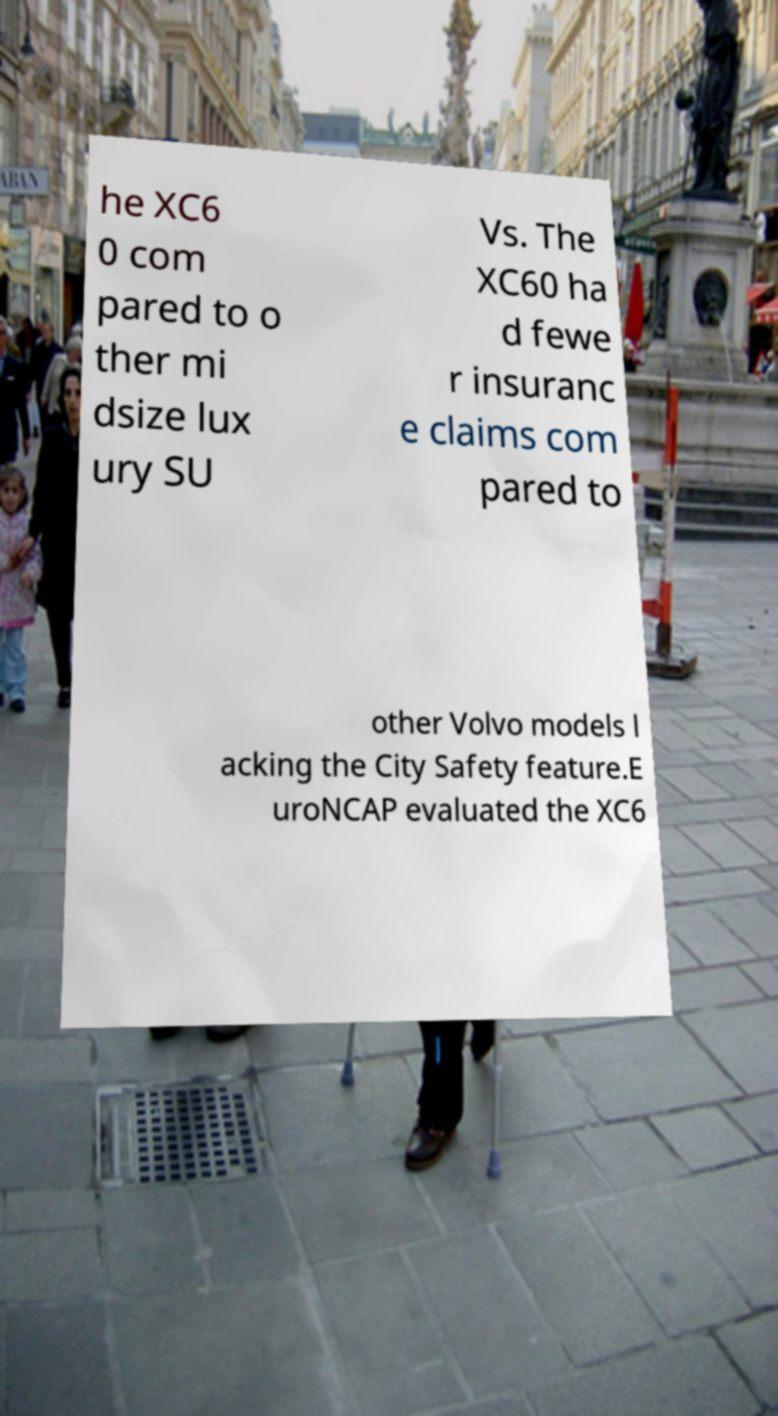What messages or text are displayed in this image? I need them in a readable, typed format. he XC6 0 com pared to o ther mi dsize lux ury SU Vs. The XC60 ha d fewe r insuranc e claims com pared to other Volvo models l acking the City Safety feature.E uroNCAP evaluated the XC6 